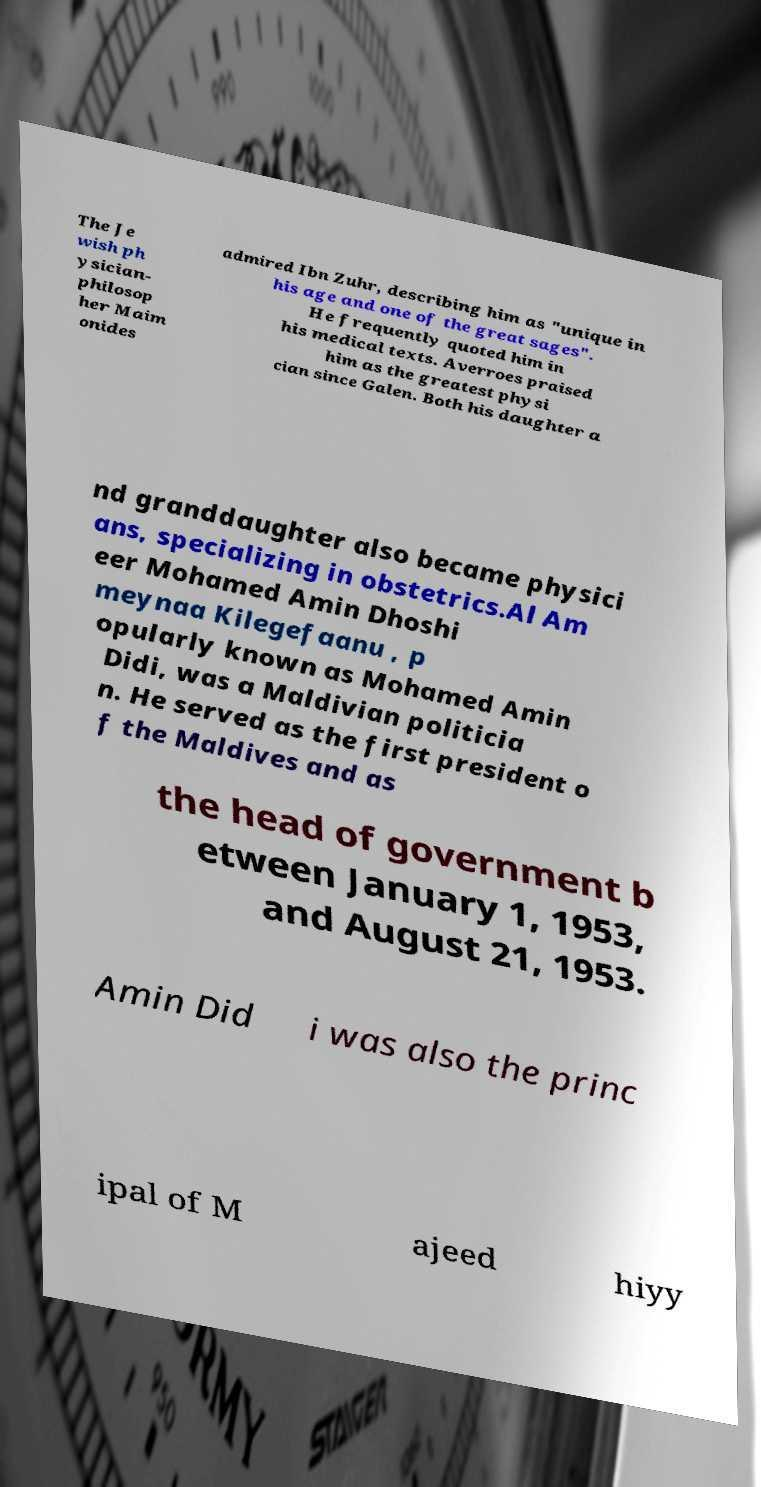I need the written content from this picture converted into text. Can you do that? The Je wish ph ysician- philosop her Maim onides admired Ibn Zuhr, describing him as "unique in his age and one of the great sages". He frequently quoted him in his medical texts. Averroes praised him as the greatest physi cian since Galen. Both his daughter a nd granddaughter also became physici ans, specializing in obstetrics.Al Am eer Mohamed Amin Dhoshi meynaa Kilegefaanu , p opularly known as Mohamed Amin Didi, was a Maldivian politicia n. He served as the first president o f the Maldives and as the head of government b etween January 1, 1953, and August 21, 1953. Amin Did i was also the princ ipal of M ajeed hiyy 